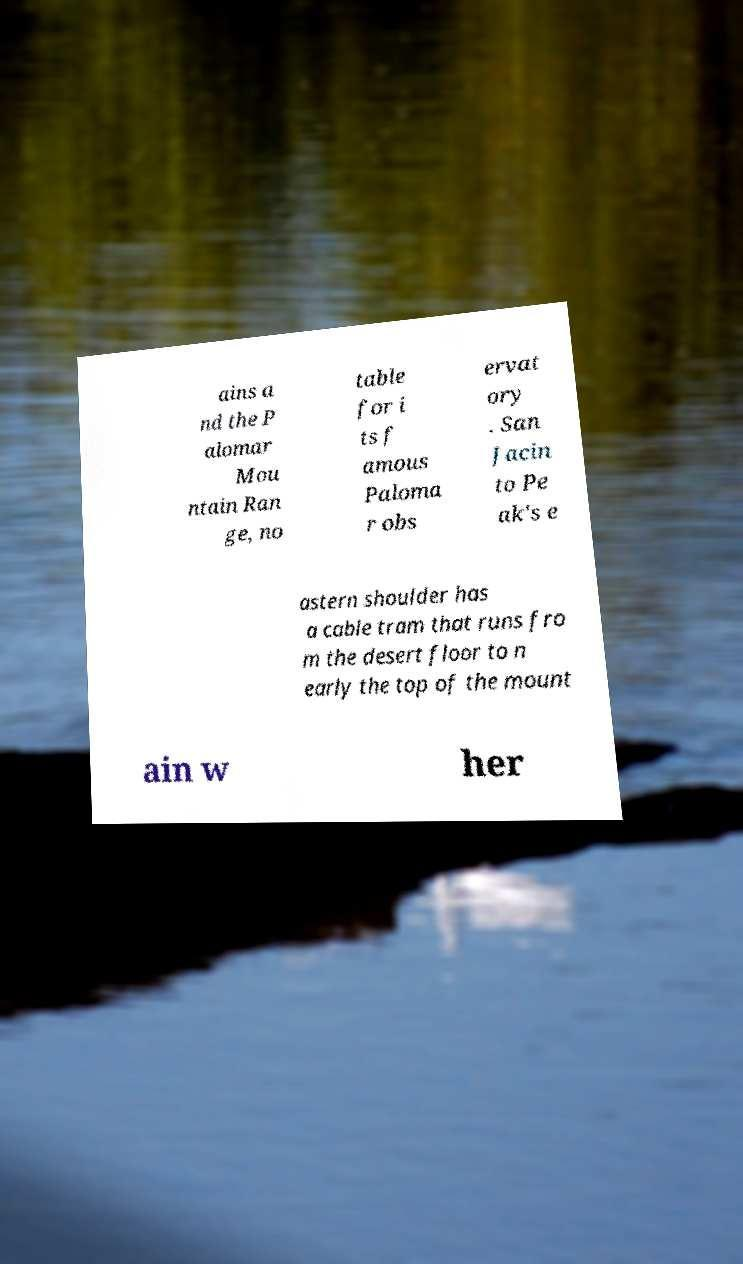Can you accurately transcribe the text from the provided image for me? ains a nd the P alomar Mou ntain Ran ge, no table for i ts f amous Paloma r obs ervat ory . San Jacin to Pe ak's e astern shoulder has a cable tram that runs fro m the desert floor to n early the top of the mount ain w her 